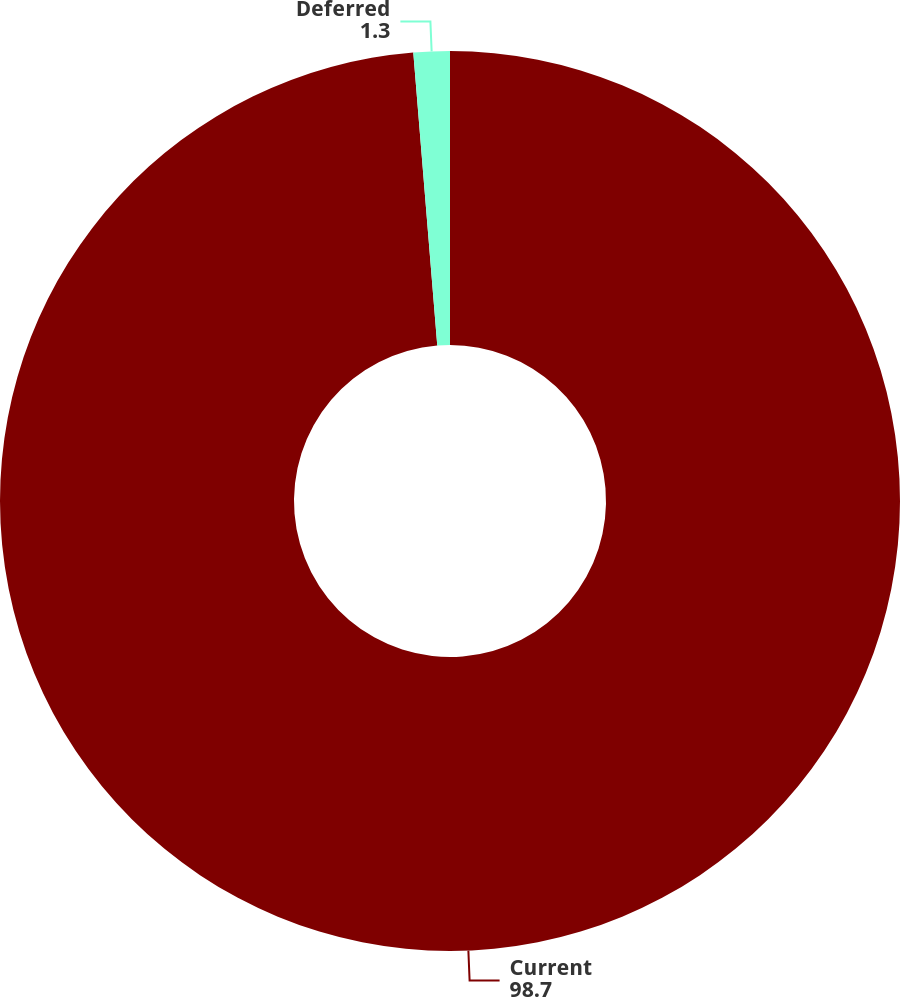<chart> <loc_0><loc_0><loc_500><loc_500><pie_chart><fcel>Current<fcel>Deferred<nl><fcel>98.7%<fcel>1.3%<nl></chart> 